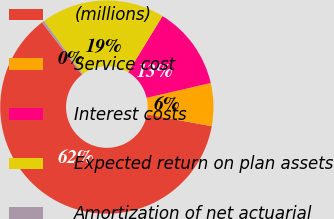Convert chart. <chart><loc_0><loc_0><loc_500><loc_500><pie_chart><fcel>(millions)<fcel>Service cost<fcel>Interest costs<fcel>Expected return on plan assets<fcel>Amortization of net actuarial<nl><fcel>61.73%<fcel>6.5%<fcel>12.64%<fcel>18.77%<fcel>0.36%<nl></chart> 